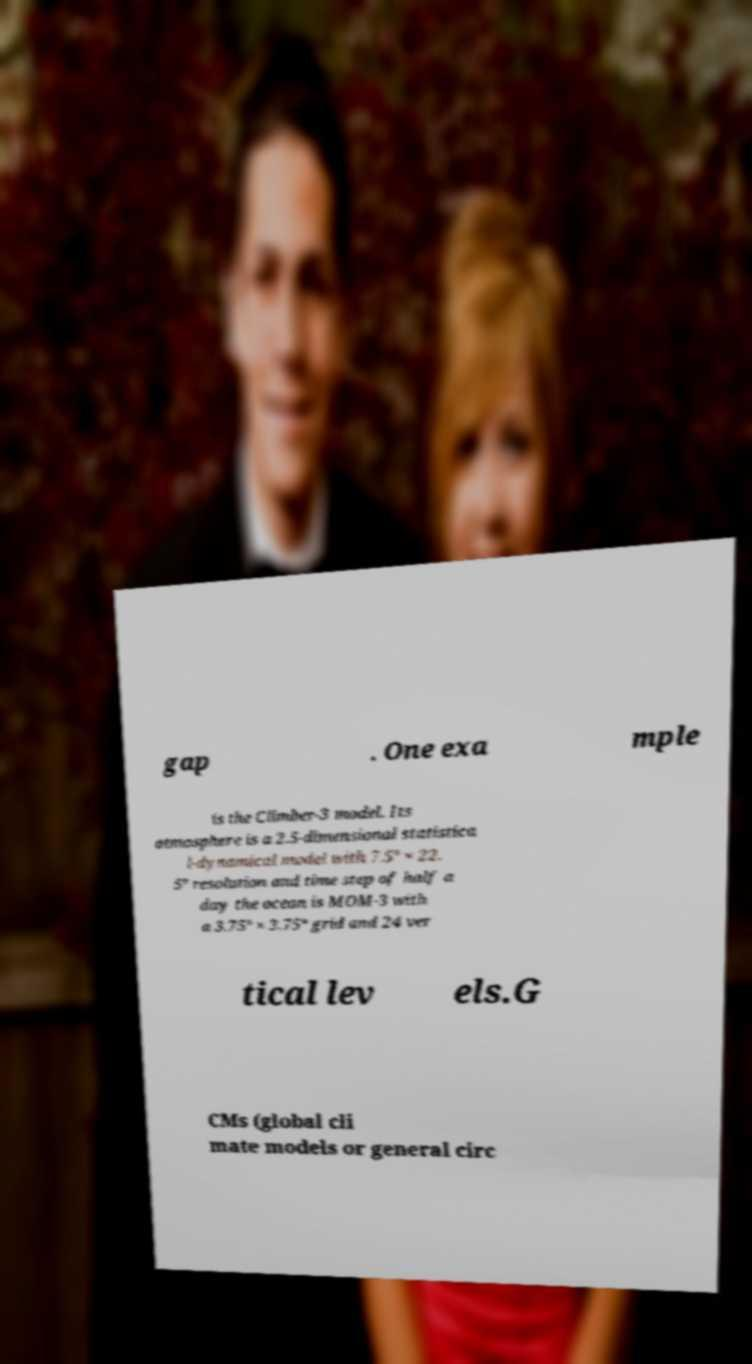Can you accurately transcribe the text from the provided image for me? gap . One exa mple is the Climber-3 model. Its atmosphere is a 2.5-dimensional statistica l-dynamical model with 7.5° × 22. 5° resolution and time step of half a day the ocean is MOM-3 with a 3.75° × 3.75° grid and 24 ver tical lev els.G CMs (global cli mate models or general circ 